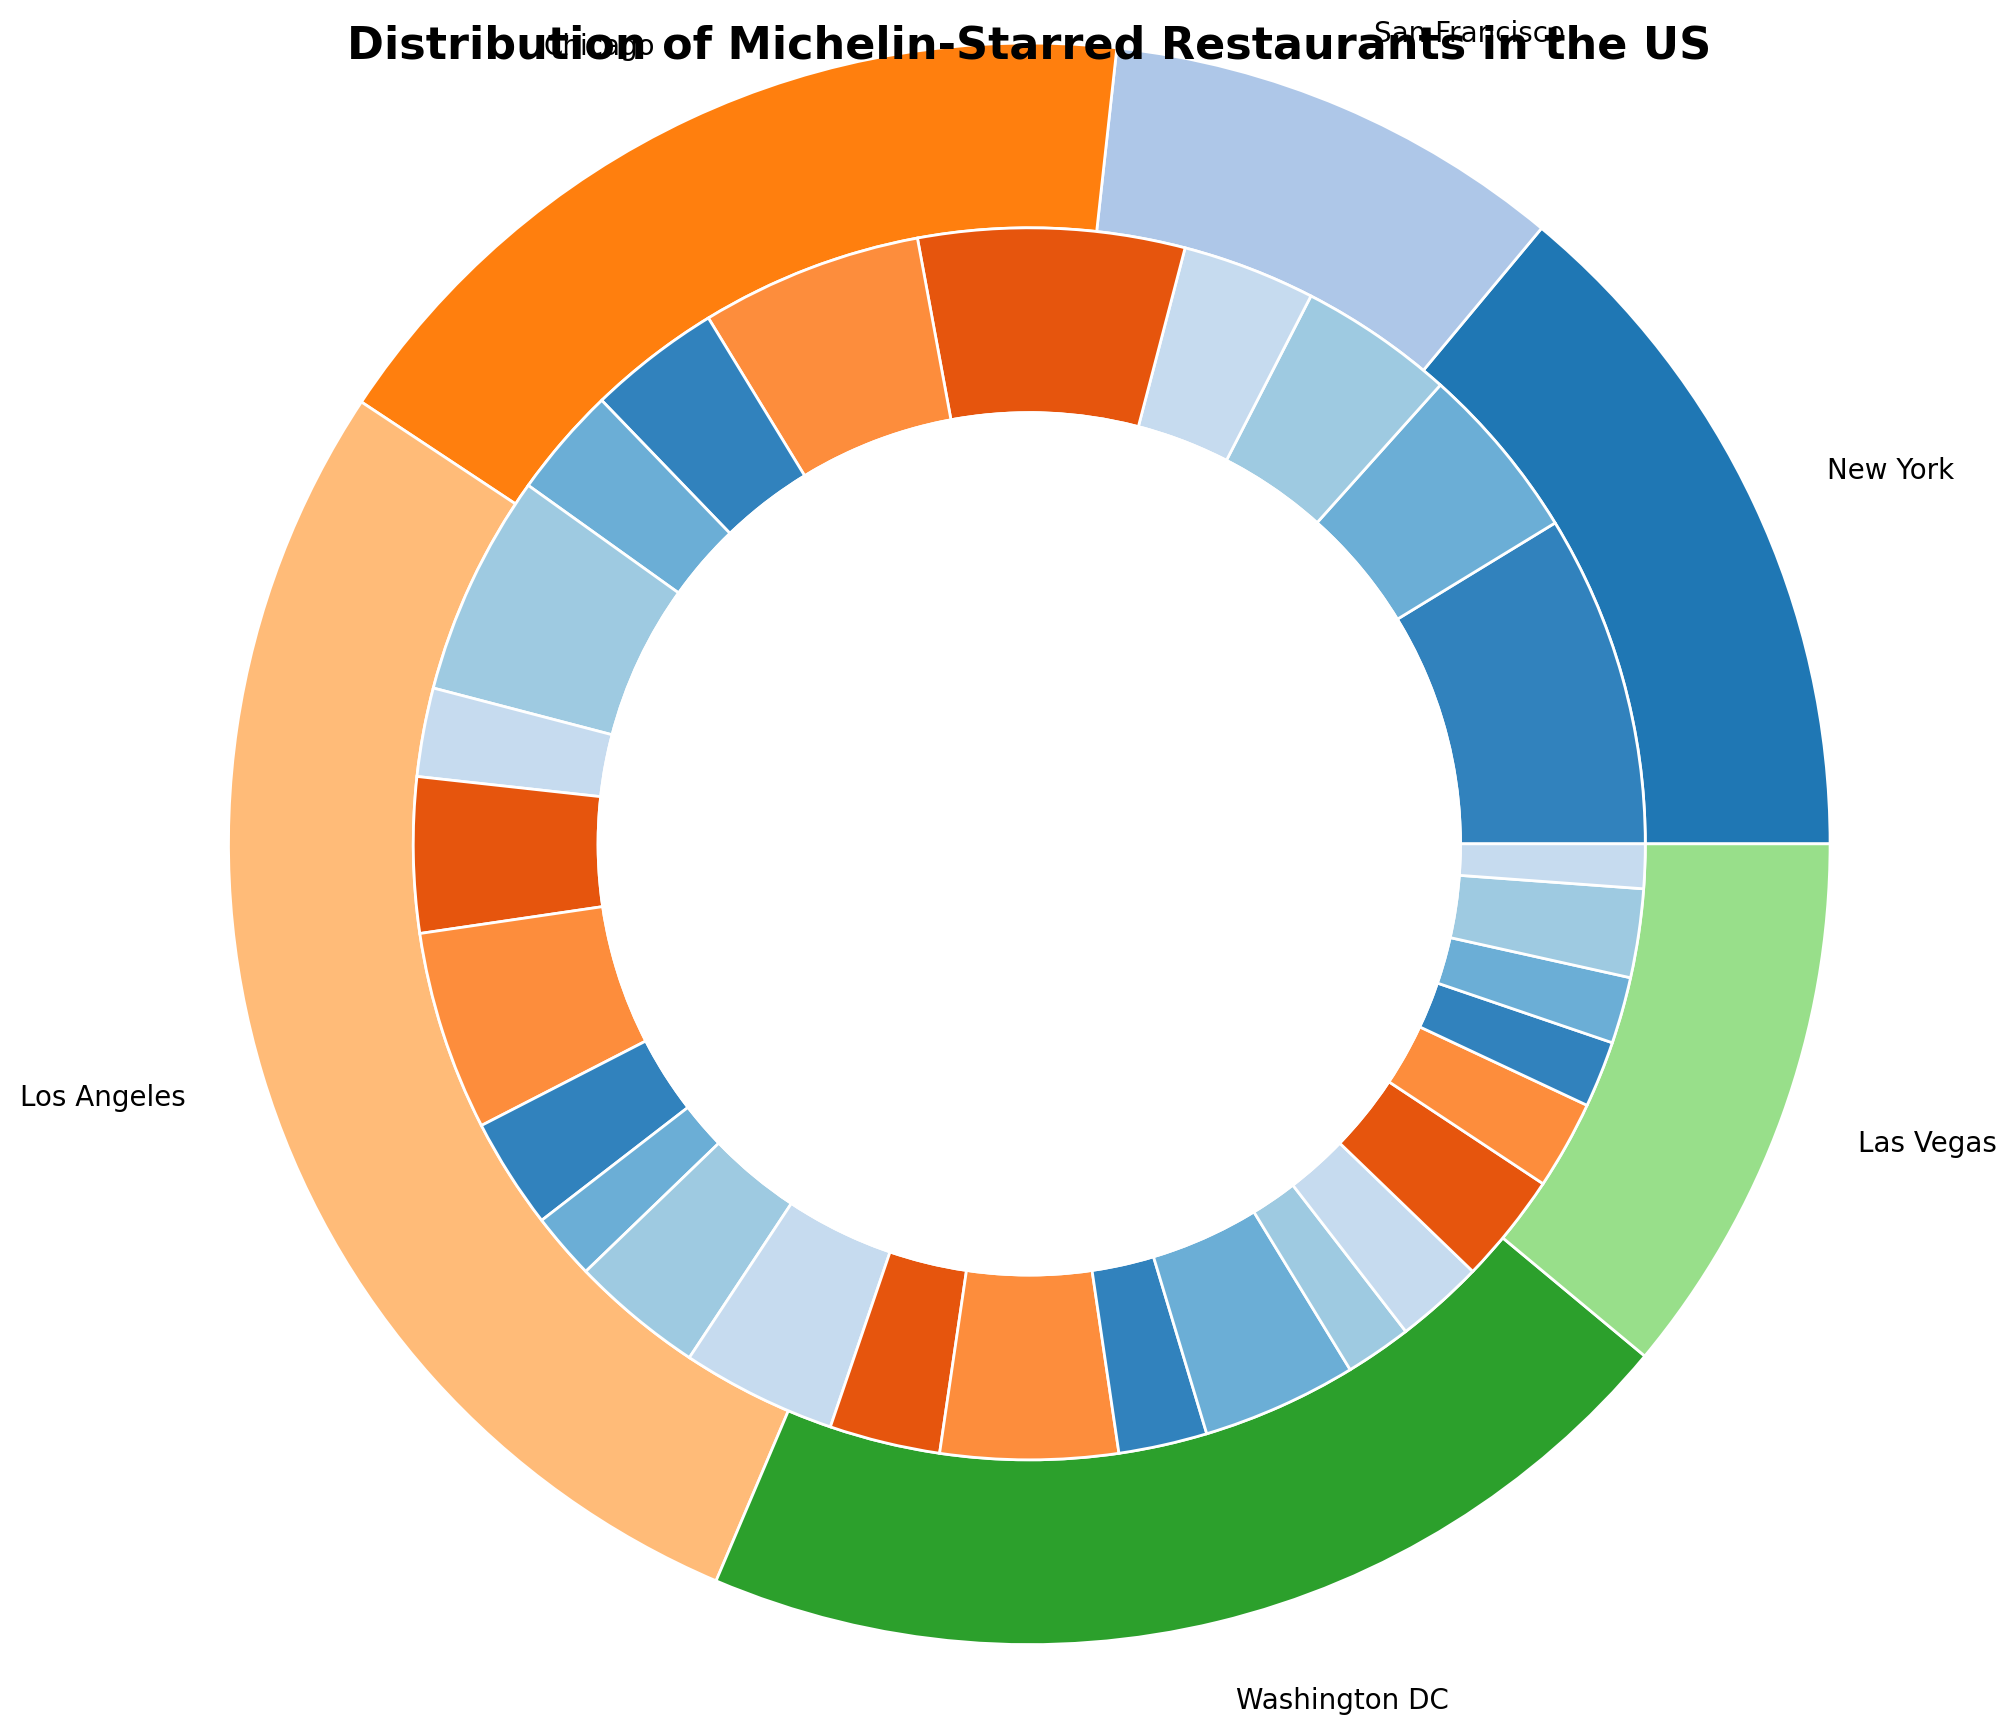What city has the largest number of Michelin-Starred restaurants? By looking at the outer ring of the pie chart, we can compare the sizes of the wedges corresponding to each city. The largest wedge represents the city with the highest number of restaurants.
Answer: New York What cuisine type is most prevalent in San Francisco Michelin-Starred restaurants? To determine this, we need to look at the inner ring segment corresponding to San Francisco in the outer ring and identify which cuisine type has the largest wedge.
Answer: French How many Michelin-Starred restaurants offering Japanese cuisine are there in New York and Los Angeles combined? We locate the inner ring segments for Japanese cuisine in both New York and Los Angeles, counting the number of restaurants in each and then summing them up (8 for New York + 7 for Los Angeles = 15).
Answer: 15 Which city has a higher count of Italian Michelin-Starred restaurants, Chicago or Washington DC? By comparing the Italian cuisine segments in the inner rings for both Chicago and Washington DC, we find that Chicago has a larger segment.
Answer: Chicago What is the total number of Contemporary cuisine Michelin-Starred restaurants across all listed cities? We need to sum the counts of Contemporary cuisine in each city: New York (6) + San Francisco (5) + Washington DC (4) + Las Vegas (3) = 18.
Answer: 18 How does the number of American cuisine Michelin-Starred restaurants in New York compare to that in San Francisco? By comparing the inner ring segments for American cuisine in both cities, we see that New York and San Francisco have the same count, both with equal-sized wedges (12 each).
Answer: Equal What percentage of Michelin-Starred restaurants in Los Angeles offer French cuisine? First, we find the total number of Michelin-Starred restaurants in Los Angeles by summing the inner ring values, then find what fraction of those are French, and calculate the percentage. Total in Los Angeles = 6 (French) + 7 (Japanese) + 5 (Italian) + 8 (American) + 4 (Mexican) = 30. Fraction for French = 6/30; Percentage = (6/30) * 100 = 20%.
Answer: 20% Between Las Vegas and Washington DC, which city has the smallest number of Michelin-Starred restaurants, and by how much do they differ? We compare the total number of restaurants in each city from the outer ring: Las Vegas has segments totaling (4 + 3 + 3 + 4 + 2 = 16) and Washington DC has (7 + 3 + 4 + 5 = 19). The difference = 19 - 16 = 3.
Answer: Las Vegas, by 3 What is the total number of Michelin-Starred French restaurants across all cities? To get the total number, we sum all the segments labeled French from the inner rings: 15 (New York) + 10 (San Francisco) + 7 (Chicago) + 6 (Los Angeles) + 5 (Washington DC) + 4 (Las Vegas) = 47.
Answer: 47 